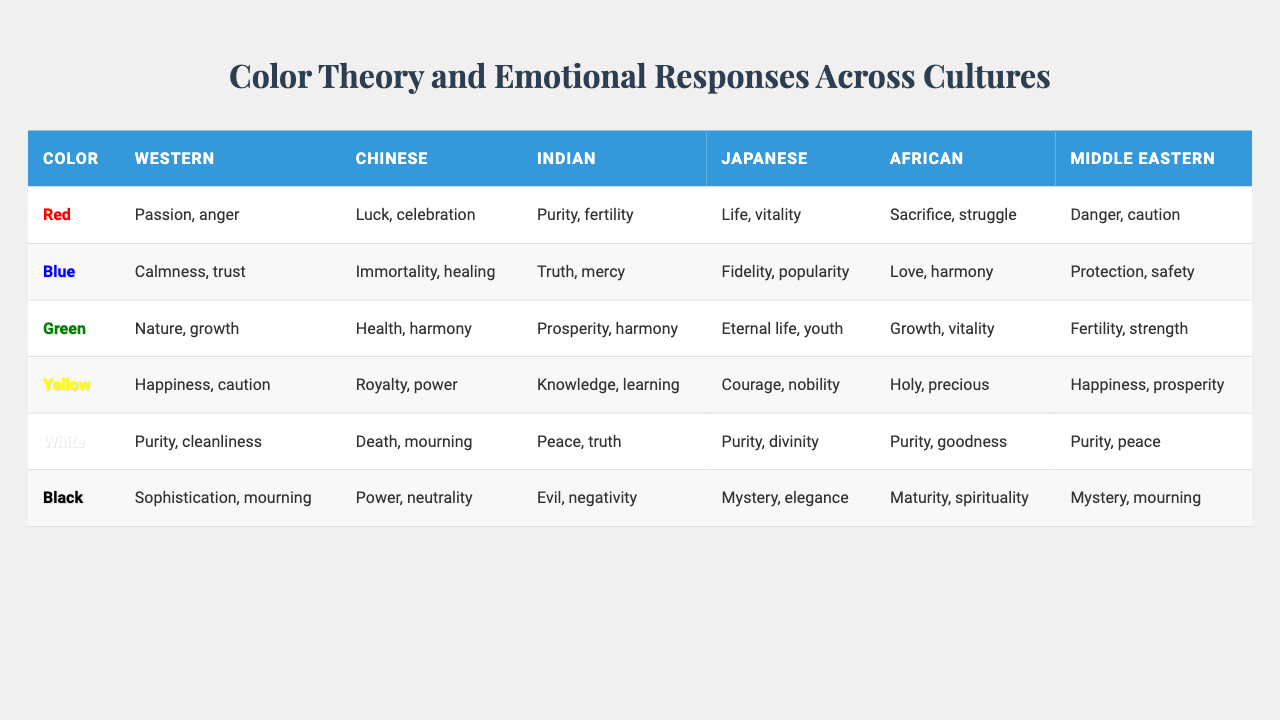What emotional response does the color white evoke in Western culture? According to the table, the emotional response associated with the color white in Western culture is "Purity, cleanliness."
Answer: Purity, cleanliness Which color is associated with the concept of luck in Chinese culture? The table indicates that the color associated with luck in Chinese culture is red.
Answer: Red Does yellow symbolize happiness in both African and Middle Eastern cultures? Yes, the table shows that both African and Middle Eastern cultures link yellow to happiness.
Answer: Yes What are the emotional responses for the color blue according to Indian culture? The emotional responses linked to blue in Indian culture, as per the table, are "Truth, mercy."
Answer: Truth, mercy In which culture is the color green associated with the feeling of vitality? The table indicates that green is associated with the feeling of vitality in both African and Japanese cultures.
Answer: African, Japanese How many cultures associate the color black with mourning? The table reveals that black is associated with mourning in Western, Chinese, and Middle Eastern cultures, making it three cultures.
Answer: Three cultures Which color is linked to the concept of purity across the most cultures? Based on the table, the color white is consistently linked to purity across Western, Chinese, Indian, Japanese, and African cultures, totaling five cultures.
Answer: Five cultures What is the difference between the emotional responses for the color red in African and Japanese cultures? The table shows that red is associated with "Sacrifice, struggle" in African culture and "Life, vitality" in Japanese culture. The difference is in the focus of emotions, with African culture emphasizing sacrifice, while Japanese culture emphasizes life and vitality.
Answer: Sacrifice, struggle vs. Life, vitality Is green viewed positively across all cultures listed? No, while green has many positive associations such as "Nature, growth" in Western culture and "Health, harmony" in Chinese culture, it is not viewed positively in Indian culture where it is tied to "Evil, negativity."
Answer: No Which color in Middle Eastern culture is linked to safety? The table specifies that the color blue is associated with protection and safety in Middle Eastern culture.
Answer: Blue Can you summarize the emotional responses for yellow in Indian culture? In Indian culture, yellow is associated with "Knowledge, learning," which emphasizes its connection to education and enlightenment, as shown in the table.
Answer: Knowledge, learning 